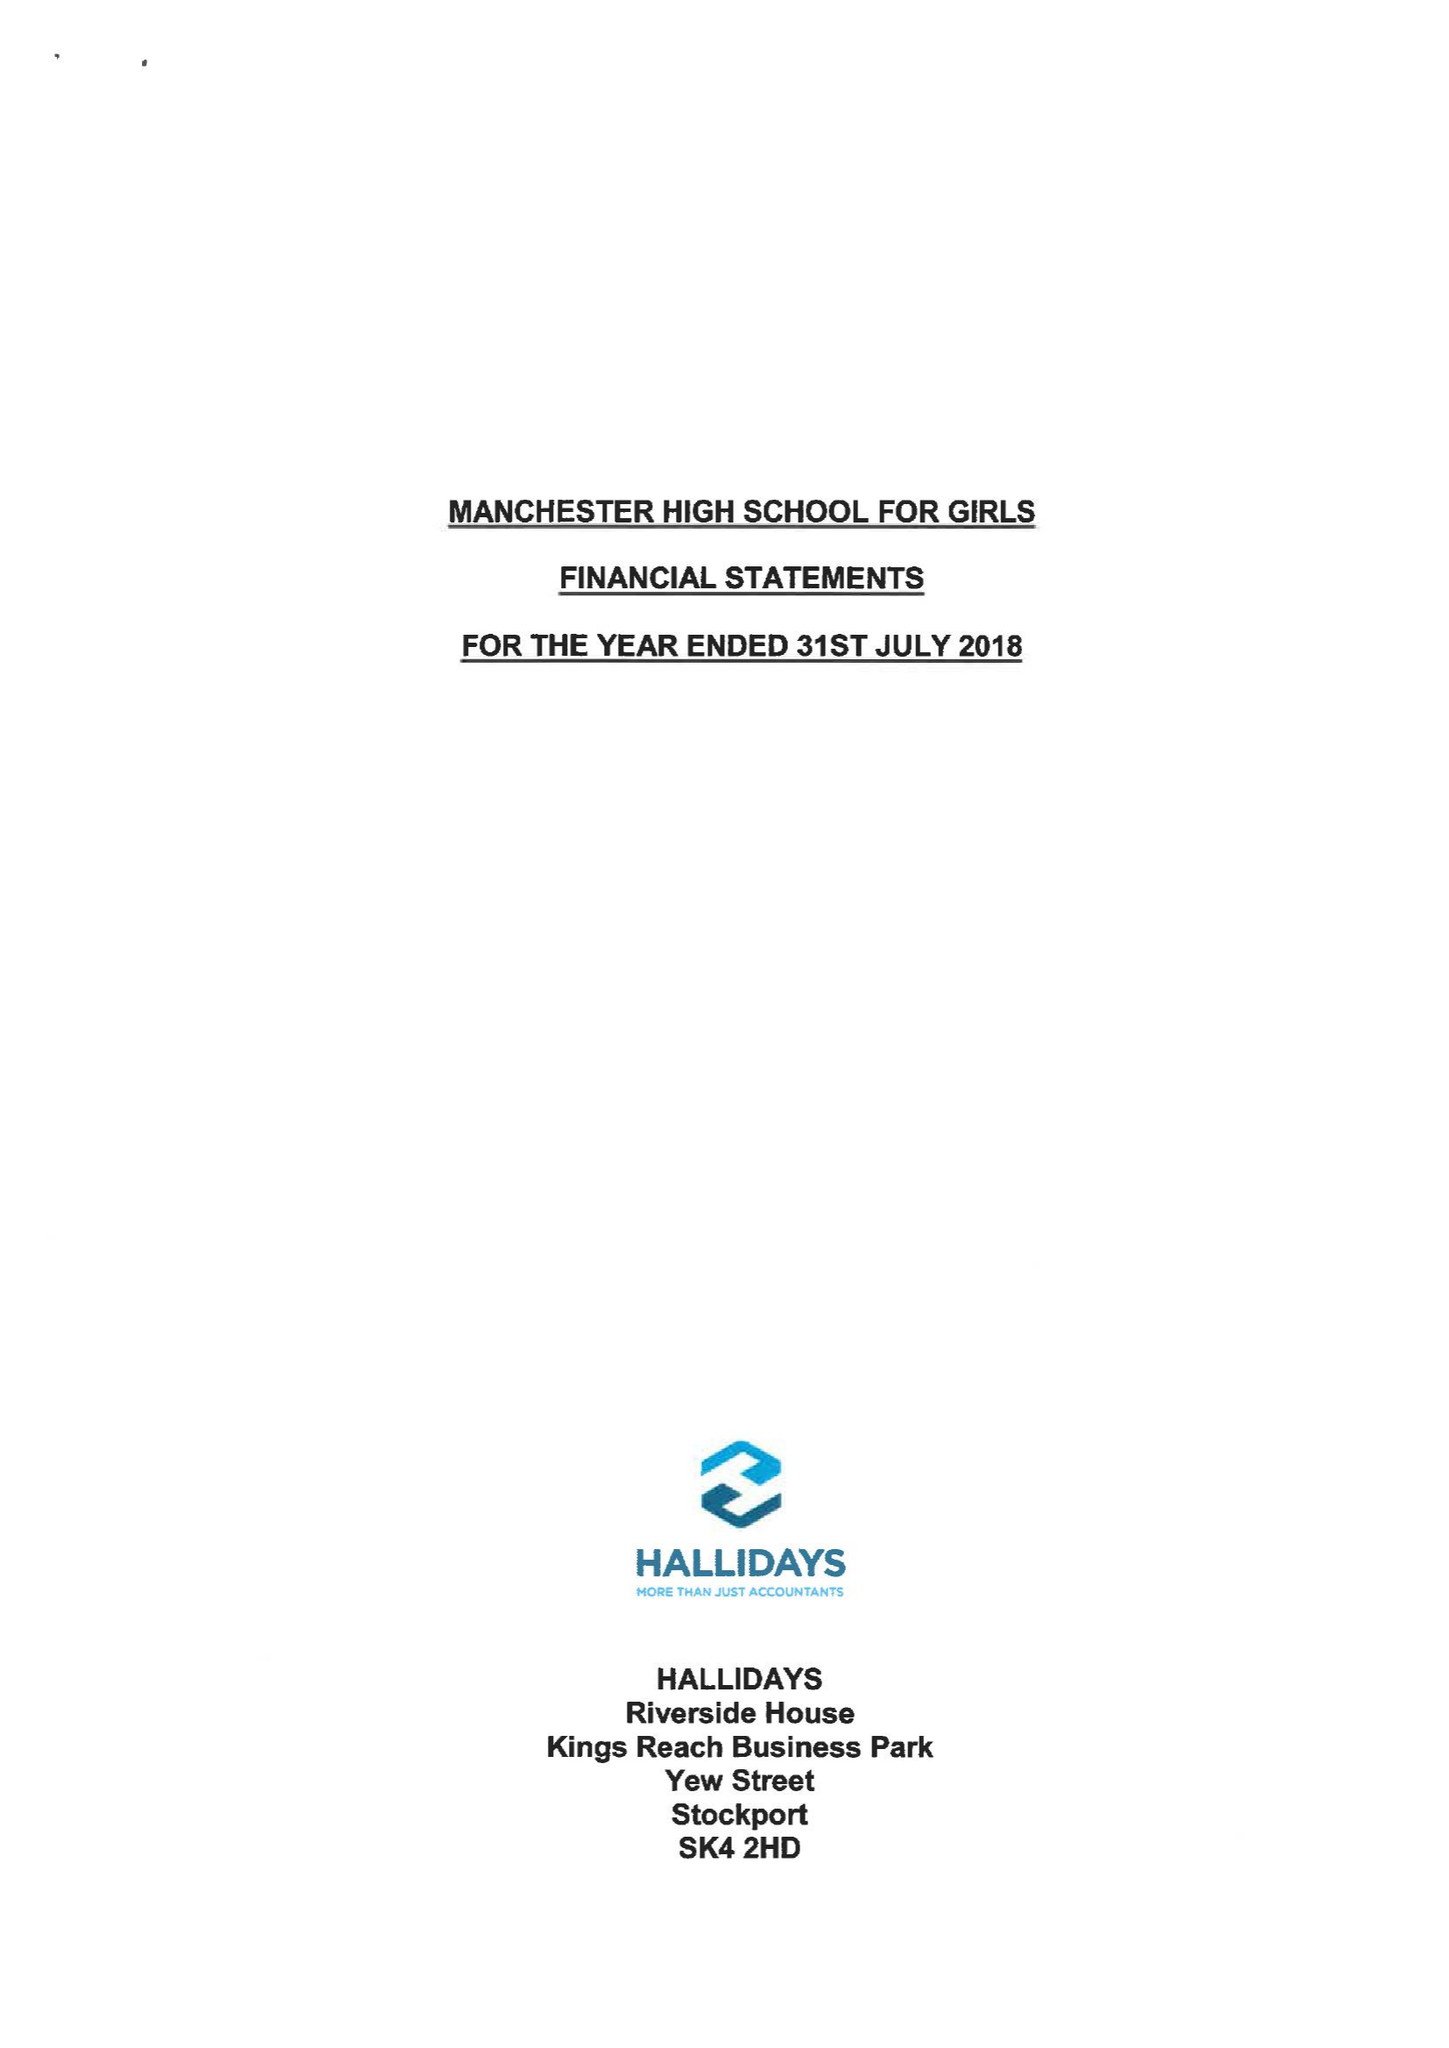What is the value for the report_date?
Answer the question using a single word or phrase. 2018-07-31 